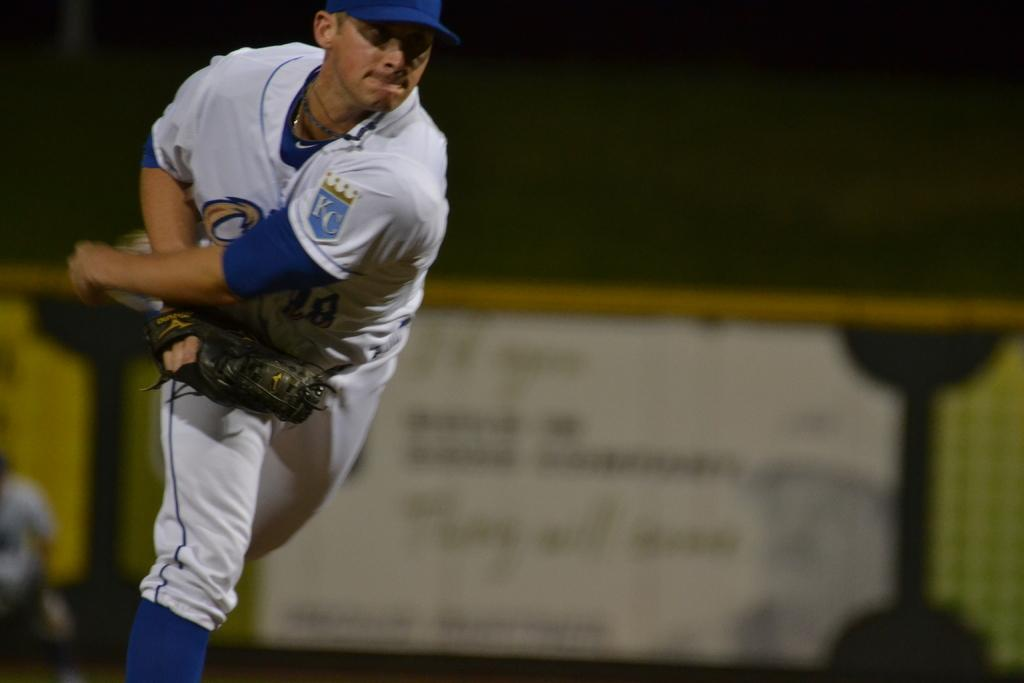<image>
Render a clear and concise summary of the photo. An athlete mid throw with a KC emblem on his left shoulder. 